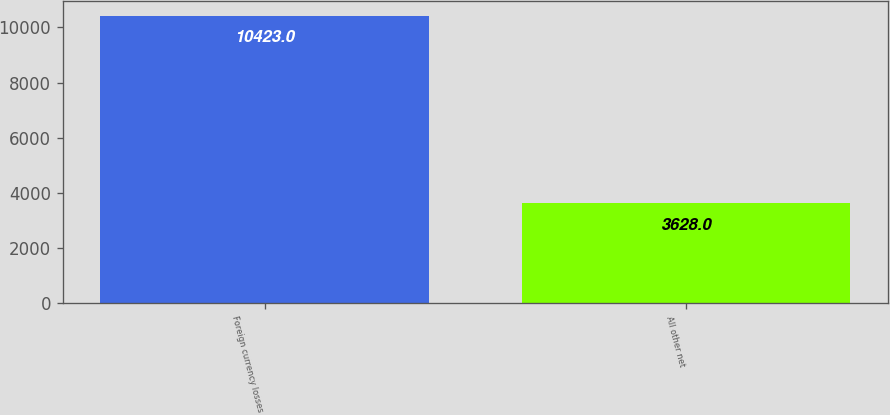<chart> <loc_0><loc_0><loc_500><loc_500><bar_chart><fcel>Foreign currency losses<fcel>All other net<nl><fcel>10423<fcel>3628<nl></chart> 